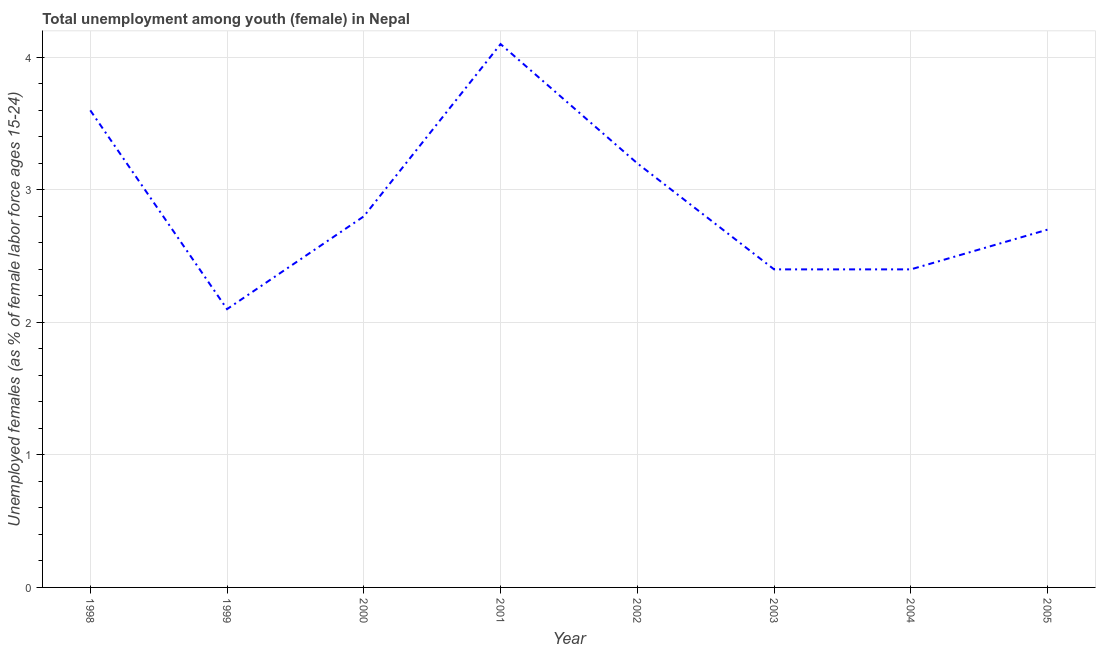What is the unemployed female youth population in 2002?
Offer a terse response. 3.2. Across all years, what is the maximum unemployed female youth population?
Ensure brevity in your answer.  4.1. Across all years, what is the minimum unemployed female youth population?
Provide a succinct answer. 2.1. What is the sum of the unemployed female youth population?
Offer a very short reply. 23.3. What is the difference between the unemployed female youth population in 2002 and 2005?
Offer a very short reply. 0.5. What is the average unemployed female youth population per year?
Your answer should be compact. 2.91. What is the median unemployed female youth population?
Offer a terse response. 2.75. In how many years, is the unemployed female youth population greater than 3.2 %?
Give a very brief answer. 3. What is the ratio of the unemployed female youth population in 1998 to that in 2000?
Provide a short and direct response. 1.29. Is the unemployed female youth population in 2001 less than that in 2004?
Provide a succinct answer. No. What is the difference between the highest and the second highest unemployed female youth population?
Offer a terse response. 0.5. What is the difference between the highest and the lowest unemployed female youth population?
Provide a succinct answer. 2. In how many years, is the unemployed female youth population greater than the average unemployed female youth population taken over all years?
Give a very brief answer. 3. How many lines are there?
Your answer should be very brief. 1. How many years are there in the graph?
Provide a short and direct response. 8. Does the graph contain any zero values?
Ensure brevity in your answer.  No. What is the title of the graph?
Keep it short and to the point. Total unemployment among youth (female) in Nepal. What is the label or title of the Y-axis?
Provide a succinct answer. Unemployed females (as % of female labor force ages 15-24). What is the Unemployed females (as % of female labor force ages 15-24) of 1998?
Your answer should be compact. 3.6. What is the Unemployed females (as % of female labor force ages 15-24) of 1999?
Your answer should be very brief. 2.1. What is the Unemployed females (as % of female labor force ages 15-24) in 2000?
Make the answer very short. 2.8. What is the Unemployed females (as % of female labor force ages 15-24) of 2001?
Give a very brief answer. 4.1. What is the Unemployed females (as % of female labor force ages 15-24) of 2002?
Your response must be concise. 3.2. What is the Unemployed females (as % of female labor force ages 15-24) of 2003?
Keep it short and to the point. 2.4. What is the Unemployed females (as % of female labor force ages 15-24) in 2004?
Provide a succinct answer. 2.4. What is the Unemployed females (as % of female labor force ages 15-24) in 2005?
Offer a very short reply. 2.7. What is the difference between the Unemployed females (as % of female labor force ages 15-24) in 1998 and 1999?
Give a very brief answer. 1.5. What is the difference between the Unemployed females (as % of female labor force ages 15-24) in 1998 and 2000?
Ensure brevity in your answer.  0.8. What is the difference between the Unemployed females (as % of female labor force ages 15-24) in 1998 and 2001?
Keep it short and to the point. -0.5. What is the difference between the Unemployed females (as % of female labor force ages 15-24) in 1999 and 2000?
Your answer should be very brief. -0.7. What is the difference between the Unemployed females (as % of female labor force ages 15-24) in 1999 and 2001?
Ensure brevity in your answer.  -2. What is the difference between the Unemployed females (as % of female labor force ages 15-24) in 1999 and 2002?
Your response must be concise. -1.1. What is the difference between the Unemployed females (as % of female labor force ages 15-24) in 1999 and 2003?
Make the answer very short. -0.3. What is the difference between the Unemployed females (as % of female labor force ages 15-24) in 1999 and 2004?
Offer a terse response. -0.3. What is the difference between the Unemployed females (as % of female labor force ages 15-24) in 2000 and 2001?
Offer a very short reply. -1.3. What is the difference between the Unemployed females (as % of female labor force ages 15-24) in 2000 and 2002?
Offer a very short reply. -0.4. What is the difference between the Unemployed females (as % of female labor force ages 15-24) in 2000 and 2004?
Offer a very short reply. 0.4. What is the difference between the Unemployed females (as % of female labor force ages 15-24) in 2001 and 2004?
Provide a succinct answer. 1.7. What is the difference between the Unemployed females (as % of female labor force ages 15-24) in 2002 and 2005?
Make the answer very short. 0.5. What is the difference between the Unemployed females (as % of female labor force ages 15-24) in 2003 and 2005?
Provide a succinct answer. -0.3. What is the difference between the Unemployed females (as % of female labor force ages 15-24) in 2004 and 2005?
Ensure brevity in your answer.  -0.3. What is the ratio of the Unemployed females (as % of female labor force ages 15-24) in 1998 to that in 1999?
Your answer should be very brief. 1.71. What is the ratio of the Unemployed females (as % of female labor force ages 15-24) in 1998 to that in 2000?
Give a very brief answer. 1.29. What is the ratio of the Unemployed females (as % of female labor force ages 15-24) in 1998 to that in 2001?
Offer a very short reply. 0.88. What is the ratio of the Unemployed females (as % of female labor force ages 15-24) in 1998 to that in 2003?
Provide a short and direct response. 1.5. What is the ratio of the Unemployed females (as % of female labor force ages 15-24) in 1998 to that in 2005?
Give a very brief answer. 1.33. What is the ratio of the Unemployed females (as % of female labor force ages 15-24) in 1999 to that in 2000?
Give a very brief answer. 0.75. What is the ratio of the Unemployed females (as % of female labor force ages 15-24) in 1999 to that in 2001?
Make the answer very short. 0.51. What is the ratio of the Unemployed females (as % of female labor force ages 15-24) in 1999 to that in 2002?
Provide a short and direct response. 0.66. What is the ratio of the Unemployed females (as % of female labor force ages 15-24) in 1999 to that in 2003?
Give a very brief answer. 0.88. What is the ratio of the Unemployed females (as % of female labor force ages 15-24) in 1999 to that in 2005?
Offer a very short reply. 0.78. What is the ratio of the Unemployed females (as % of female labor force ages 15-24) in 2000 to that in 2001?
Your answer should be compact. 0.68. What is the ratio of the Unemployed females (as % of female labor force ages 15-24) in 2000 to that in 2002?
Make the answer very short. 0.88. What is the ratio of the Unemployed females (as % of female labor force ages 15-24) in 2000 to that in 2003?
Ensure brevity in your answer.  1.17. What is the ratio of the Unemployed females (as % of female labor force ages 15-24) in 2000 to that in 2004?
Offer a very short reply. 1.17. What is the ratio of the Unemployed females (as % of female labor force ages 15-24) in 2000 to that in 2005?
Ensure brevity in your answer.  1.04. What is the ratio of the Unemployed females (as % of female labor force ages 15-24) in 2001 to that in 2002?
Your answer should be very brief. 1.28. What is the ratio of the Unemployed females (as % of female labor force ages 15-24) in 2001 to that in 2003?
Your answer should be very brief. 1.71. What is the ratio of the Unemployed females (as % of female labor force ages 15-24) in 2001 to that in 2004?
Give a very brief answer. 1.71. What is the ratio of the Unemployed females (as % of female labor force ages 15-24) in 2001 to that in 2005?
Your answer should be very brief. 1.52. What is the ratio of the Unemployed females (as % of female labor force ages 15-24) in 2002 to that in 2003?
Offer a very short reply. 1.33. What is the ratio of the Unemployed females (as % of female labor force ages 15-24) in 2002 to that in 2004?
Your answer should be compact. 1.33. What is the ratio of the Unemployed females (as % of female labor force ages 15-24) in 2002 to that in 2005?
Keep it short and to the point. 1.19. What is the ratio of the Unemployed females (as % of female labor force ages 15-24) in 2003 to that in 2004?
Offer a very short reply. 1. What is the ratio of the Unemployed females (as % of female labor force ages 15-24) in 2003 to that in 2005?
Provide a succinct answer. 0.89. What is the ratio of the Unemployed females (as % of female labor force ages 15-24) in 2004 to that in 2005?
Provide a succinct answer. 0.89. 